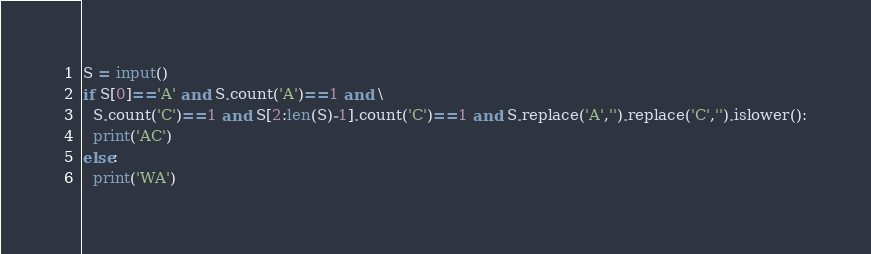Convert code to text. <code><loc_0><loc_0><loc_500><loc_500><_Python_>S = input()
if S[0]=='A' and S.count('A')==1 and \
  S.count('C')==1 and S[2:len(S)-1].count('C')==1 and S.replace('A','').replace('C','').islower():
  print('AC')
else:
  print('WA')</code> 